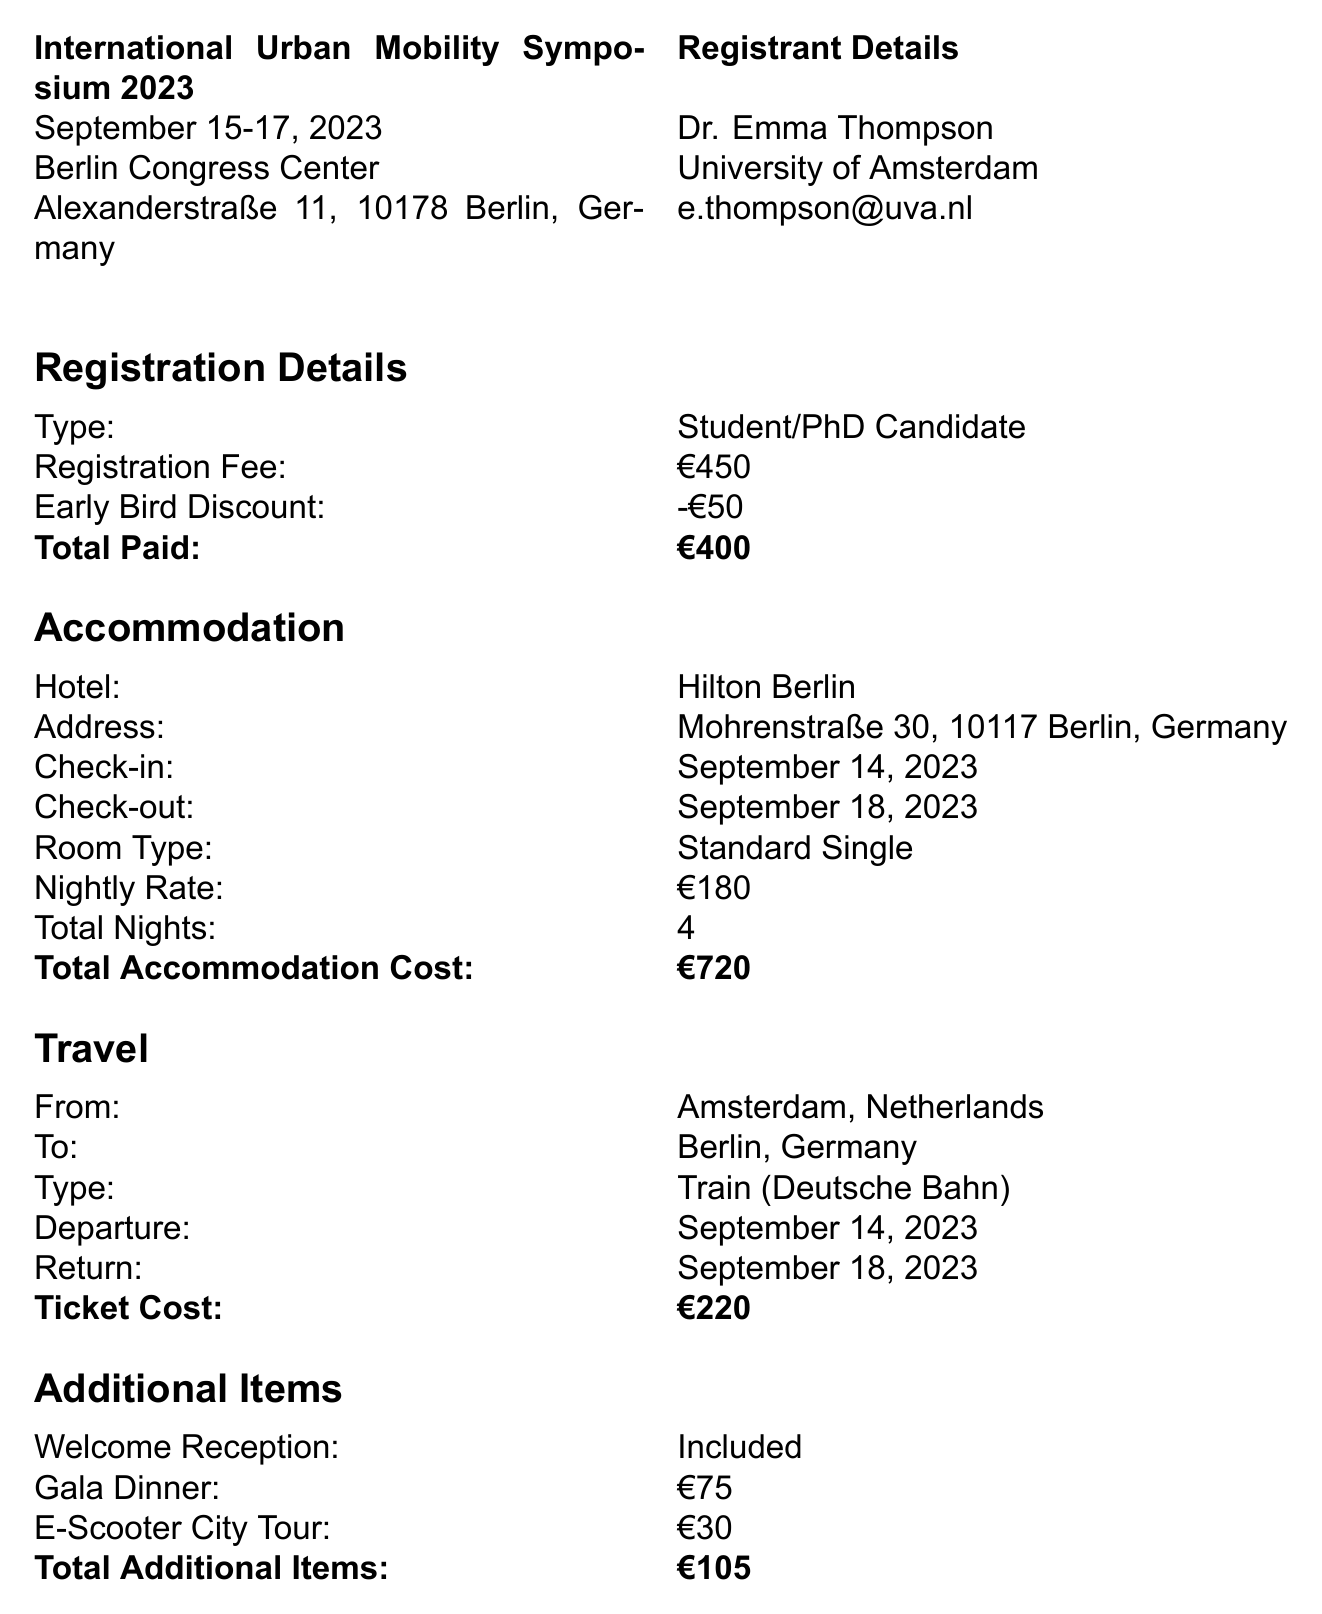What is the name of the conference? The conference name is provided in the document, which states "International Urban Mobility Symposium 2023."
Answer: International Urban Mobility Symposium 2023 What is the registration fee type? The document specifies the registration fee type as "Student/PhD Candidate."
Answer: Student/PhD Candidate What is the total accommodation cost? The total accommodation cost is listed in the document as €720.
Answer: €720 How many nights is the accommodation booked for? The document indicates a total of 4 nights for accommodation.
Answer: 4 What is the check-out date from the hotel? The check-out date for the hotel is mentioned in the document as "September 18, 2023."
Answer: September 18, 2023 What is the total cost for additional items? The document summarizes that the total cost for additional items is €105.
Answer: €105 What method was used to process the payment? The document states the payment method was a credit card, which was a Visa.
Answer: Credit Card (Visa) How much was paid in total for registration? According to the document, the total paid for registration is €400.
Answer: €400 What is the receipt number? The receipt number is explicitly provided in the document as "IUMS2023-5689."
Answer: IUMS2023-5689 